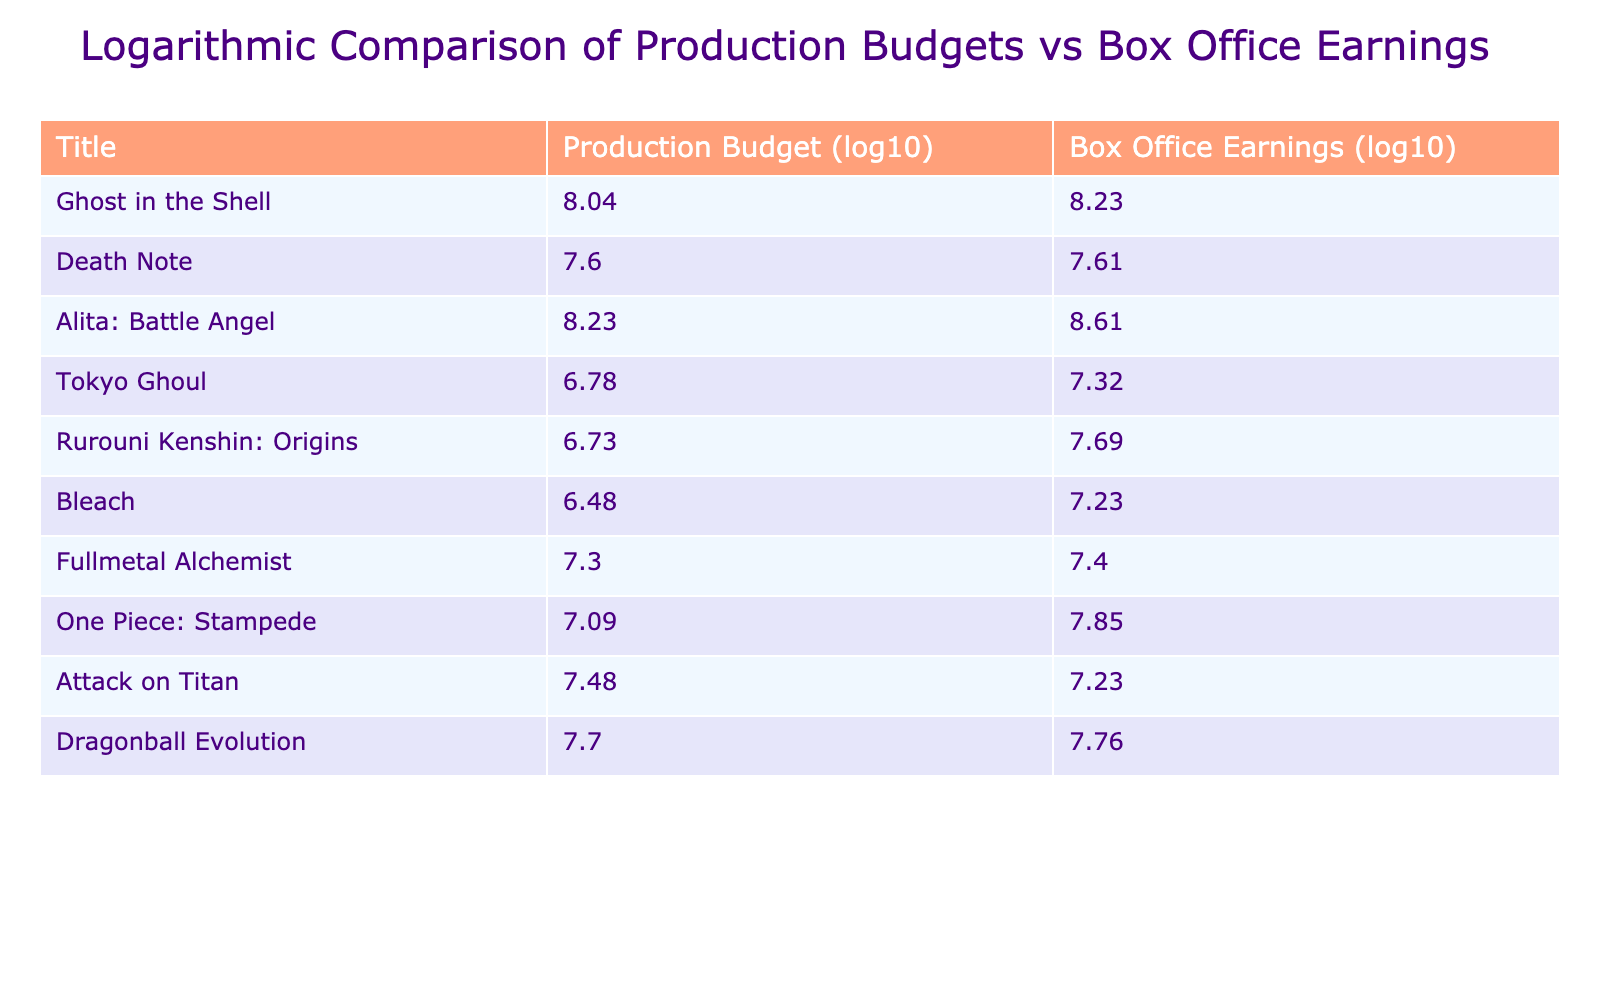What is the production budget for "Alita: Battle Angel"? The production budget for "Alita: Battle Angel" is directly stated in the table. According to the entry for this title, the budget is 170,000,000.
Answer: 170000000 Which movie had the lowest production budget? To find the lowest budget, we can look for the smallest value in the Production Budget column. The entry for "Bleach" lists a budget of 3,000,000, which is smaller than the budgets for all other titles.
Answer: 3000000 What is the average box office earnings for all movies in the table? We need to sum the box office earnings from each entry and divide by the total number of movies (10). The total earnings are 1,791,000,000, and thus the average is 1,791,000,000/10 = 179,100,000.
Answer: 179100000 Did "Tokyo Ghoul" earn more at the box office than its production budget? To answer this, compare the box office earnings of "Tokyo Ghoul" (20,800,000) with its production budget (6,000,000). Since 20,800,000 is greater than 6,000,000, we can confirm that it did earn more than its budget.
Answer: Yes Which movie shows the greatest difference between box office earnings and production budget? This involves calculating the difference for each movie by subtracting the production budget from the box office earnings. The greatest difference is for "Alita: Battle Angel," which has an earnings of 404,800,000 and a budget of 170,000,000, resulting in a difference of 234,800,000.
Answer: Alita: Battle Angel What is the ratio of production budget to box office earnings for "Death Note"? This requires dividing the production budget of "Death Note" (40,000,000) by its box office earnings (40,500,000). The ratio is 40,000,000 / 40,500,000, which is approximately 0.9877 or rounded to 0.99.
Answer: 0.99 Is the production budget for "Dragonball Evolution" more than double its box office earnings? To determine this, we compare the production budget of "Dragonball Evolution" (50,000,000) with double its box office earnings (57,000,000). Since 50,000,000 is less than 114,000,000 (twice 57,000,000), the answer is no.
Answer: No Which film had box office earnings below 30 million? Reviewing the box office earnings listed in the table, "Bleach" (17,000,000), "Tokyo Ghoul" (20,800,000), and "Fullmetal Alchemist" (25,000,000) all earned below the 30 million mark.
Answer: Bleach, Tokyo Ghoul, Fullmetal Alchemist 